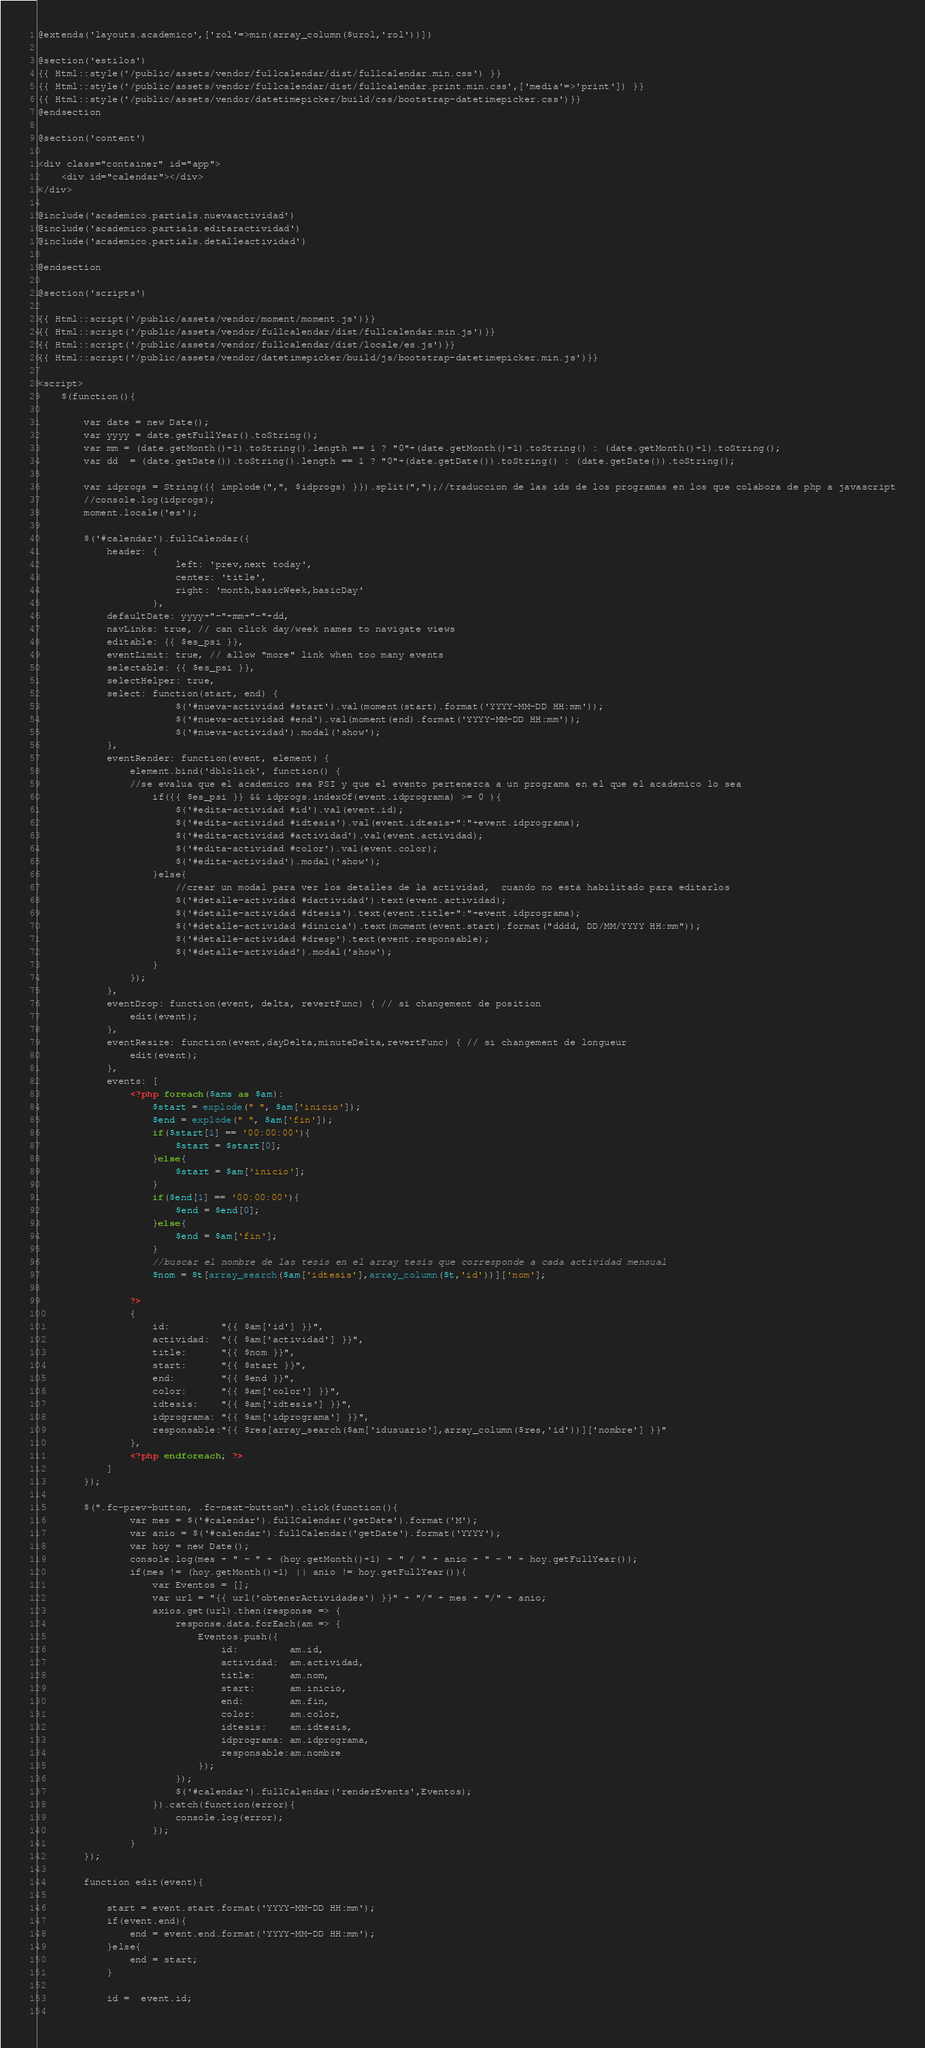<code> <loc_0><loc_0><loc_500><loc_500><_PHP_>@extends('layouts.academico',['rol'=>min(array_column($urol,'rol'))])

@section('estilos')
{{ Html::style('/public/assets/vendor/fullcalendar/dist/fullcalendar.min.css') }}
{{ Html::style('/public/assets/vendor/fullcalendar/dist/fullcalendar.print.min.css',['media'=>'print']) }}
{{ Html::style('/public/assets/vendor/datetimepicker/build/css/bootstrap-datetimepicker.css')}}
@endsection

@section('content')

<div class="container" id="app">	
	<div id="calendar"></div>
</div>

@include('academico.partials.nuevaactividad')
@include('academico.partials.editaractividad')
@include('academico.partials.detalleactividad')

@endsection

@section('scripts')

{{ Html::script('/public/assets/vendor/moment/moment.js')}}
{{ Html::script('/public/assets/vendor/fullcalendar/dist/fullcalendar.min.js')}}
{{ Html::script('/public/assets/vendor/fullcalendar/dist/locale/es.js')}}
{{ Html::script('/public/assets/vendor/datetimepicker/build/js/bootstrap-datetimepicker.min.js')}}

<script>
	$(function(){
		
		var date = new Date();
       	var yyyy = date.getFullYear().toString();
       	var mm = (date.getMonth()+1).toString().length == 1 ? "0"+(date.getMonth()+1).toString() : (date.getMonth()+1).toString();
       	var dd  = (date.getDate()).toString().length == 1 ? "0"+(date.getDate()).toString() : (date.getDate()).toString();	

       	var idprogs = String({{ implode(",", $idprogs) }}).split(",");//traduccion de las ids de los programas en los que colabora de php a javascript
       	//console.log(idprogs);	
       	moment.locale('es');

		$('#calendar').fullCalendar({
    		header: {
        				left: 'prev,next today',
				        center: 'title',
				        right: 'month,basicWeek,basicDay'
				    },
			defaultDate: yyyy+"-"+mm+"-"+dd,
		    navLinks: true, // can click day/week names to navigate views		    
			editable: {{ $es_psi }},
			eventLimit: true, // allow "more" link when too many events
			selectable: {{ $es_psi }},
			selectHelper: true,
			select: function(start, end) {				
						$('#nueva-actividad #start').val(moment(start).format('YYYY-MM-DD HH:mm'));
						$('#nueva-actividad #end').val(moment(end).format('YYYY-MM-DD HH:mm'));
						$('#nueva-actividad').modal('show');
			},
			eventRender: function(event, element) {
				element.bind('dblclick', function() {
				//se evalua que el academico sea PSI y que el evento pertenezca a un programa en el que el academico lo sea
					if({{ $es_psi }} && idprogs.indexOf(event.idprograma) >= 0 ){
						$('#edita-actividad #id').val(event.id);
						$('#edita-actividad #idtesis').val(event.idtesis+":"+event.idprograma);					
						$('#edita-actividad #actividad').val(event.actividad);
						$('#edita-actividad #color').val(event.color);
						$('#edita-actividad').modal('show');
					}else{
						//crear un modal para ver los detalles de la actividad,  cuando no está habilitado para editarlos
						$('#detalle-actividad #dactividad').text(event.actividad);
						$('#detalle-actividad #dtesis').text(event.title+":"+event.idprograma);					
						$('#detalle-actividad #dinicia').text(moment(event.start).format("dddd, DD/MM/YYYY HH:mm"));
						$('#detalle-actividad #dresp').text(event.responsable);
						$('#detalle-actividad').modal('show');
					}
				});
			},	
			eventDrop: function(event, delta, revertFunc) { // si changement de position
				edit(event);
			},
			eventResize: function(event,dayDelta,minuteDelta,revertFunc) { // si changement de longueur
				edit(event);
			},
			events: [
				<?php foreach($ams as $am): 
					$start = explode(" ", $am['inicio']);
					$end = explode(" ", $am['fin']);
					if($start[1] == '00:00:00'){
						$start = $start[0];
					}else{
						$start = $am['inicio'];
					}
					if($end[1] == '00:00:00'){
						$end = $end[0];
					}else{
						$end = $am['fin'];
					}
					//buscar el nombre de las tesis en el array tesis que corresponde a cada actividad mensual
					$nom = $t[array_search($am['idtesis'],array_column($t,'id'))]['nom'];

				?>
				{
					id: 		"{{ $am['id'] }}",
					actividad: 	"{{ $am['actividad'] }}",
					title: 		"{{ $nom }}",
					start: 		"{{ $start }}",
					end: 		"{{ $end }}",
					color: 		"{{ $am['color'] }}",
					idtesis: 	"{{ $am['idtesis'] }}",
					idprograma: "{{ $am['idprograma'] }}",
					responsable:"{{ $res[array_search($am['idusuario'],array_column($res,'id'))]['nombre'] }}"
				},
				<?php endforeach; ?>
			]					    
  		});
		
		$(".fc-prev-button, .fc-next-button").click(function(){			
				var mes = $('#calendar').fullCalendar('getDate').format('M');
				var anio = $('#calendar').fullCalendar('getDate').format('YYYY');
				var hoy = new Date();
				console.log(mes + " - " + (hoy.getMonth()+1) + " / " + anio + " - " + hoy.getFullYear());
				if(mes != (hoy.getMonth()+1) || anio != hoy.getFullYear()){
					var Eventos = [];					
					var url = "{{ url('obtenerActividades') }}" + "/" + mes + "/" + anio;
					axios.get(url).then(response => {						
						response.data.forEach(am => {
							Eventos.push({
								id: 		am.id,
								actividad: 	am.actividad,
								title: 		am.nom,
								start: 		am.inicio,
								end: 		am.fin,
								color: 		am.color,
								idtesis: 	am.idtesis,
								idprograma: am.idprograma,
								responsable:am.nombre								
							});
						});
						$('#calendar').fullCalendar('renderEvents',Eventos);					
					}).catch(function(error){
						console.log(error);
					});
				}
		});

		function edit(event){
			
			start = event.start.format('YYYY-MM-DD HH:mm');
			if(event.end){
				end = event.end.format('YYYY-MM-DD HH:mm');
			}else{
				end = start;
			}
			
			id =  event.id;
			</code> 